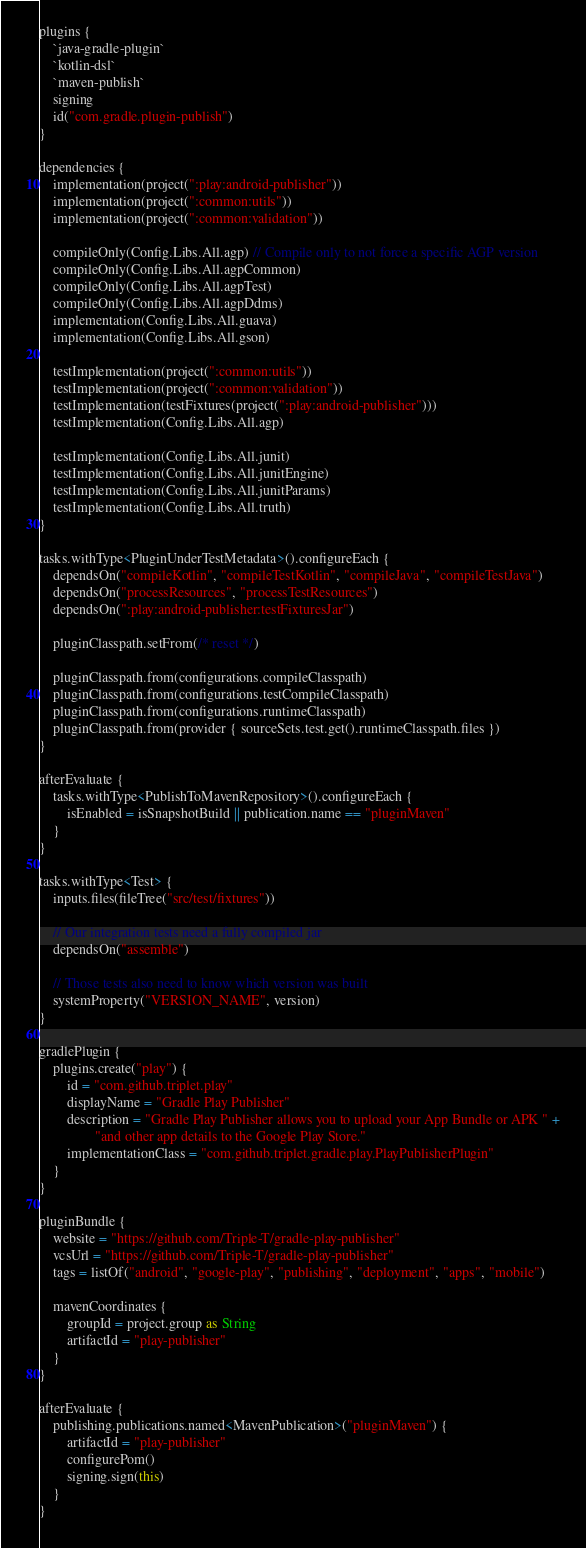Convert code to text. <code><loc_0><loc_0><loc_500><loc_500><_Kotlin_>plugins {
    `java-gradle-plugin`
    `kotlin-dsl`
    `maven-publish`
    signing
    id("com.gradle.plugin-publish")
}

dependencies {
    implementation(project(":play:android-publisher"))
    implementation(project(":common:utils"))
    implementation(project(":common:validation"))

    compileOnly(Config.Libs.All.agp) // Compile only to not force a specific AGP version
    compileOnly(Config.Libs.All.agpCommon)
    compileOnly(Config.Libs.All.agpTest)
    compileOnly(Config.Libs.All.agpDdms)
    implementation(Config.Libs.All.guava)
    implementation(Config.Libs.All.gson)

    testImplementation(project(":common:utils"))
    testImplementation(project(":common:validation"))
    testImplementation(testFixtures(project(":play:android-publisher")))
    testImplementation(Config.Libs.All.agp)

    testImplementation(Config.Libs.All.junit)
    testImplementation(Config.Libs.All.junitEngine)
    testImplementation(Config.Libs.All.junitParams)
    testImplementation(Config.Libs.All.truth)
}

tasks.withType<PluginUnderTestMetadata>().configureEach {
    dependsOn("compileKotlin", "compileTestKotlin", "compileJava", "compileTestJava")
    dependsOn("processResources", "processTestResources")
    dependsOn(":play:android-publisher:testFixturesJar")

    pluginClasspath.setFrom(/* reset */)

    pluginClasspath.from(configurations.compileClasspath)
    pluginClasspath.from(configurations.testCompileClasspath)
    pluginClasspath.from(configurations.runtimeClasspath)
    pluginClasspath.from(provider { sourceSets.test.get().runtimeClasspath.files })
}

afterEvaluate {
    tasks.withType<PublishToMavenRepository>().configureEach {
        isEnabled = isSnapshotBuild || publication.name == "pluginMaven"
    }
}

tasks.withType<Test> {
    inputs.files(fileTree("src/test/fixtures"))

    // Our integration tests need a fully compiled jar
    dependsOn("assemble")

    // Those tests also need to know which version was built
    systemProperty("VERSION_NAME", version)
}

gradlePlugin {
    plugins.create("play") {
        id = "com.github.triplet.play"
        displayName = "Gradle Play Publisher"
        description = "Gradle Play Publisher allows you to upload your App Bundle or APK " +
                "and other app details to the Google Play Store."
        implementationClass = "com.github.triplet.gradle.play.PlayPublisherPlugin"
    }
}

pluginBundle {
    website = "https://github.com/Triple-T/gradle-play-publisher"
    vcsUrl = "https://github.com/Triple-T/gradle-play-publisher"
    tags = listOf("android", "google-play", "publishing", "deployment", "apps", "mobile")

    mavenCoordinates {
        groupId = project.group as String
        artifactId = "play-publisher"
    }
}

afterEvaluate {
    publishing.publications.named<MavenPublication>("pluginMaven") {
        artifactId = "play-publisher"
        configurePom()
        signing.sign(this)
    }
}
</code> 